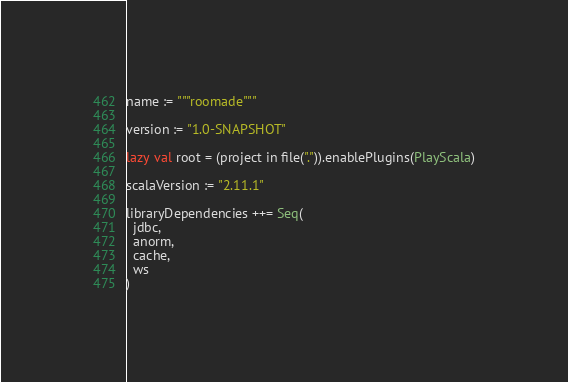Convert code to text. <code><loc_0><loc_0><loc_500><loc_500><_Scala_>name := """roomade"""

version := "1.0-SNAPSHOT"

lazy val root = (project in file(".")).enablePlugins(PlayScala)

scalaVersion := "2.11.1"

libraryDependencies ++= Seq(
  jdbc,
  anorm,
  cache,
  ws
)
</code> 